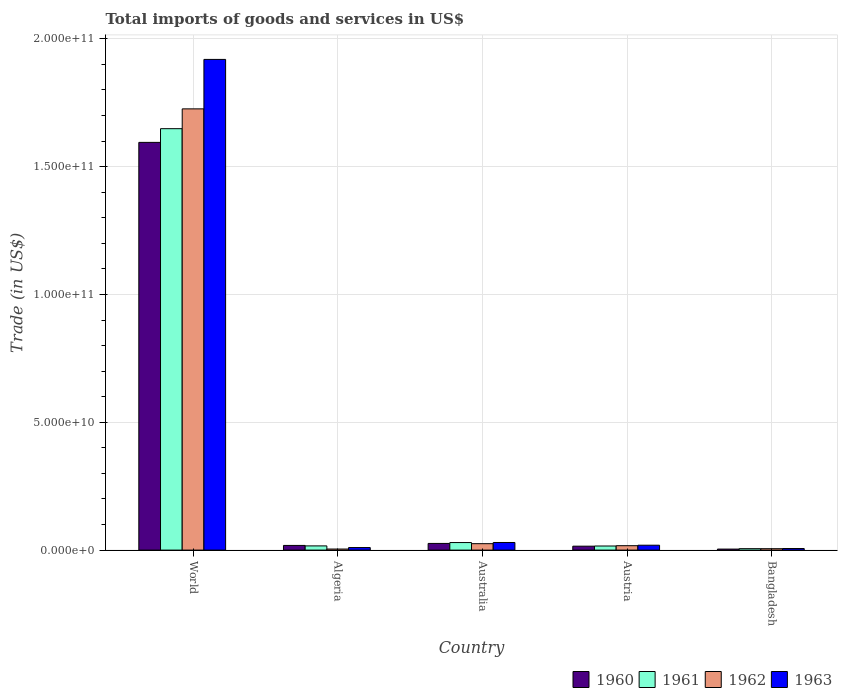How many different coloured bars are there?
Offer a terse response. 4. How many groups of bars are there?
Your answer should be very brief. 5. Are the number of bars per tick equal to the number of legend labels?
Offer a very short reply. Yes. In how many cases, is the number of bars for a given country not equal to the number of legend labels?
Make the answer very short. 0. What is the total imports of goods and services in 1962 in Algeria?
Provide a succinct answer. 4.17e+08. Across all countries, what is the maximum total imports of goods and services in 1962?
Offer a terse response. 1.73e+11. Across all countries, what is the minimum total imports of goods and services in 1962?
Keep it short and to the point. 4.17e+08. In which country was the total imports of goods and services in 1960 maximum?
Your answer should be compact. World. In which country was the total imports of goods and services in 1962 minimum?
Offer a very short reply. Algeria. What is the total total imports of goods and services in 1961 in the graph?
Offer a terse response. 1.72e+11. What is the difference between the total imports of goods and services in 1963 in Australia and that in Austria?
Offer a very short reply. 1.06e+09. What is the difference between the total imports of goods and services in 1961 in World and the total imports of goods and services in 1960 in Austria?
Make the answer very short. 1.63e+11. What is the average total imports of goods and services in 1960 per country?
Your answer should be very brief. 3.32e+1. What is the difference between the total imports of goods and services of/in 1963 and total imports of goods and services of/in 1960 in Bangladesh?
Keep it short and to the point. 2.22e+08. What is the ratio of the total imports of goods and services in 1961 in Algeria to that in World?
Keep it short and to the point. 0.01. Is the difference between the total imports of goods and services in 1963 in Australia and Bangladesh greater than the difference between the total imports of goods and services in 1960 in Australia and Bangladesh?
Your answer should be very brief. Yes. What is the difference between the highest and the second highest total imports of goods and services in 1960?
Keep it short and to the point. -7.83e+08. What is the difference between the highest and the lowest total imports of goods and services in 1961?
Your answer should be compact. 1.64e+11. Is the sum of the total imports of goods and services in 1963 in Austria and Bangladesh greater than the maximum total imports of goods and services in 1961 across all countries?
Offer a very short reply. No. Is it the case that in every country, the sum of the total imports of goods and services in 1962 and total imports of goods and services in 1961 is greater than the sum of total imports of goods and services in 1963 and total imports of goods and services in 1960?
Your answer should be very brief. No. What does the 3rd bar from the left in World represents?
Your answer should be compact. 1962. What does the 3rd bar from the right in Bangladesh represents?
Your response must be concise. 1961. Is it the case that in every country, the sum of the total imports of goods and services in 1961 and total imports of goods and services in 1960 is greater than the total imports of goods and services in 1963?
Provide a short and direct response. Yes. Are the values on the major ticks of Y-axis written in scientific E-notation?
Give a very brief answer. Yes. Does the graph contain grids?
Make the answer very short. Yes. What is the title of the graph?
Your answer should be compact. Total imports of goods and services in US$. Does "2009" appear as one of the legend labels in the graph?
Ensure brevity in your answer.  No. What is the label or title of the Y-axis?
Your answer should be compact. Trade (in US$). What is the Trade (in US$) in 1960 in World?
Provide a succinct answer. 1.59e+11. What is the Trade (in US$) in 1961 in World?
Keep it short and to the point. 1.65e+11. What is the Trade (in US$) of 1962 in World?
Keep it short and to the point. 1.73e+11. What is the Trade (in US$) in 1963 in World?
Offer a terse response. 1.92e+11. What is the Trade (in US$) of 1960 in Algeria?
Your answer should be very brief. 1.83e+09. What is the Trade (in US$) in 1961 in Algeria?
Offer a very short reply. 1.64e+09. What is the Trade (in US$) in 1962 in Algeria?
Make the answer very short. 4.17e+08. What is the Trade (in US$) of 1963 in Algeria?
Your answer should be very brief. 9.95e+08. What is the Trade (in US$) in 1960 in Australia?
Offer a very short reply. 2.61e+09. What is the Trade (in US$) in 1961 in Australia?
Keep it short and to the point. 2.95e+09. What is the Trade (in US$) of 1962 in Australia?
Your answer should be compact. 2.51e+09. What is the Trade (in US$) in 1963 in Australia?
Your answer should be compact. 2.97e+09. What is the Trade (in US$) of 1960 in Austria?
Make the answer very short. 1.53e+09. What is the Trade (in US$) in 1961 in Austria?
Your response must be concise. 1.60e+09. What is the Trade (in US$) of 1962 in Austria?
Offer a terse response. 1.72e+09. What is the Trade (in US$) in 1963 in Austria?
Give a very brief answer. 1.91e+09. What is the Trade (in US$) of 1960 in Bangladesh?
Provide a succinct answer. 3.98e+08. What is the Trade (in US$) of 1961 in Bangladesh?
Provide a succinct answer. 5.64e+08. What is the Trade (in US$) in 1962 in Bangladesh?
Your answer should be compact. 5.49e+08. What is the Trade (in US$) of 1963 in Bangladesh?
Make the answer very short. 6.20e+08. Across all countries, what is the maximum Trade (in US$) of 1960?
Give a very brief answer. 1.59e+11. Across all countries, what is the maximum Trade (in US$) in 1961?
Make the answer very short. 1.65e+11. Across all countries, what is the maximum Trade (in US$) in 1962?
Provide a short and direct response. 1.73e+11. Across all countries, what is the maximum Trade (in US$) in 1963?
Your response must be concise. 1.92e+11. Across all countries, what is the minimum Trade (in US$) of 1960?
Ensure brevity in your answer.  3.98e+08. Across all countries, what is the minimum Trade (in US$) of 1961?
Ensure brevity in your answer.  5.64e+08. Across all countries, what is the minimum Trade (in US$) in 1962?
Provide a succinct answer. 4.17e+08. Across all countries, what is the minimum Trade (in US$) of 1963?
Give a very brief answer. 6.20e+08. What is the total Trade (in US$) in 1960 in the graph?
Offer a very short reply. 1.66e+11. What is the total Trade (in US$) in 1961 in the graph?
Keep it short and to the point. 1.72e+11. What is the total Trade (in US$) of 1962 in the graph?
Your answer should be very brief. 1.78e+11. What is the total Trade (in US$) in 1963 in the graph?
Provide a short and direct response. 1.98e+11. What is the difference between the Trade (in US$) in 1960 in World and that in Algeria?
Offer a terse response. 1.58e+11. What is the difference between the Trade (in US$) in 1961 in World and that in Algeria?
Give a very brief answer. 1.63e+11. What is the difference between the Trade (in US$) of 1962 in World and that in Algeria?
Your answer should be compact. 1.72e+11. What is the difference between the Trade (in US$) of 1963 in World and that in Algeria?
Make the answer very short. 1.91e+11. What is the difference between the Trade (in US$) in 1960 in World and that in Australia?
Give a very brief answer. 1.57e+11. What is the difference between the Trade (in US$) of 1961 in World and that in Australia?
Keep it short and to the point. 1.62e+11. What is the difference between the Trade (in US$) of 1962 in World and that in Australia?
Your answer should be very brief. 1.70e+11. What is the difference between the Trade (in US$) of 1963 in World and that in Australia?
Make the answer very short. 1.89e+11. What is the difference between the Trade (in US$) in 1960 in World and that in Austria?
Ensure brevity in your answer.  1.58e+11. What is the difference between the Trade (in US$) of 1961 in World and that in Austria?
Your answer should be compact. 1.63e+11. What is the difference between the Trade (in US$) of 1962 in World and that in Austria?
Your response must be concise. 1.71e+11. What is the difference between the Trade (in US$) in 1963 in World and that in Austria?
Your answer should be very brief. 1.90e+11. What is the difference between the Trade (in US$) of 1960 in World and that in Bangladesh?
Offer a terse response. 1.59e+11. What is the difference between the Trade (in US$) in 1961 in World and that in Bangladesh?
Your answer should be very brief. 1.64e+11. What is the difference between the Trade (in US$) in 1962 in World and that in Bangladesh?
Your answer should be compact. 1.72e+11. What is the difference between the Trade (in US$) of 1963 in World and that in Bangladesh?
Your answer should be very brief. 1.91e+11. What is the difference between the Trade (in US$) of 1960 in Algeria and that in Australia?
Your response must be concise. -7.83e+08. What is the difference between the Trade (in US$) of 1961 in Algeria and that in Australia?
Offer a terse response. -1.31e+09. What is the difference between the Trade (in US$) of 1962 in Algeria and that in Australia?
Your answer should be very brief. -2.10e+09. What is the difference between the Trade (in US$) in 1963 in Algeria and that in Australia?
Keep it short and to the point. -1.98e+09. What is the difference between the Trade (in US$) of 1960 in Algeria and that in Austria?
Ensure brevity in your answer.  2.95e+08. What is the difference between the Trade (in US$) in 1961 in Algeria and that in Austria?
Your answer should be compact. 4.21e+07. What is the difference between the Trade (in US$) of 1962 in Algeria and that in Austria?
Ensure brevity in your answer.  -1.31e+09. What is the difference between the Trade (in US$) of 1963 in Algeria and that in Austria?
Ensure brevity in your answer.  -9.19e+08. What is the difference between the Trade (in US$) in 1960 in Algeria and that in Bangladesh?
Provide a short and direct response. 1.43e+09. What is the difference between the Trade (in US$) of 1961 in Algeria and that in Bangladesh?
Make the answer very short. 1.08e+09. What is the difference between the Trade (in US$) of 1962 in Algeria and that in Bangladesh?
Provide a succinct answer. -1.33e+08. What is the difference between the Trade (in US$) in 1963 in Algeria and that in Bangladesh?
Provide a succinct answer. 3.75e+08. What is the difference between the Trade (in US$) of 1960 in Australia and that in Austria?
Provide a succinct answer. 1.08e+09. What is the difference between the Trade (in US$) in 1961 in Australia and that in Austria?
Provide a short and direct response. 1.35e+09. What is the difference between the Trade (in US$) of 1962 in Australia and that in Austria?
Your answer should be very brief. 7.90e+08. What is the difference between the Trade (in US$) in 1963 in Australia and that in Austria?
Ensure brevity in your answer.  1.06e+09. What is the difference between the Trade (in US$) of 1960 in Australia and that in Bangladesh?
Provide a succinct answer. 2.21e+09. What is the difference between the Trade (in US$) in 1961 in Australia and that in Bangladesh?
Your response must be concise. 2.39e+09. What is the difference between the Trade (in US$) in 1962 in Australia and that in Bangladesh?
Ensure brevity in your answer.  1.96e+09. What is the difference between the Trade (in US$) in 1963 in Australia and that in Bangladesh?
Provide a succinct answer. 2.35e+09. What is the difference between the Trade (in US$) of 1960 in Austria and that in Bangladesh?
Ensure brevity in your answer.  1.14e+09. What is the difference between the Trade (in US$) in 1961 in Austria and that in Bangladesh?
Provide a short and direct response. 1.04e+09. What is the difference between the Trade (in US$) in 1962 in Austria and that in Bangladesh?
Provide a succinct answer. 1.17e+09. What is the difference between the Trade (in US$) of 1963 in Austria and that in Bangladesh?
Ensure brevity in your answer.  1.29e+09. What is the difference between the Trade (in US$) of 1960 in World and the Trade (in US$) of 1961 in Algeria?
Your answer should be compact. 1.58e+11. What is the difference between the Trade (in US$) of 1960 in World and the Trade (in US$) of 1962 in Algeria?
Keep it short and to the point. 1.59e+11. What is the difference between the Trade (in US$) in 1960 in World and the Trade (in US$) in 1963 in Algeria?
Offer a terse response. 1.58e+11. What is the difference between the Trade (in US$) of 1961 in World and the Trade (in US$) of 1962 in Algeria?
Keep it short and to the point. 1.64e+11. What is the difference between the Trade (in US$) of 1961 in World and the Trade (in US$) of 1963 in Algeria?
Give a very brief answer. 1.64e+11. What is the difference between the Trade (in US$) in 1962 in World and the Trade (in US$) in 1963 in Algeria?
Provide a short and direct response. 1.72e+11. What is the difference between the Trade (in US$) of 1960 in World and the Trade (in US$) of 1961 in Australia?
Keep it short and to the point. 1.57e+11. What is the difference between the Trade (in US$) in 1960 in World and the Trade (in US$) in 1962 in Australia?
Provide a succinct answer. 1.57e+11. What is the difference between the Trade (in US$) in 1960 in World and the Trade (in US$) in 1963 in Australia?
Provide a short and direct response. 1.57e+11. What is the difference between the Trade (in US$) in 1961 in World and the Trade (in US$) in 1962 in Australia?
Your answer should be compact. 1.62e+11. What is the difference between the Trade (in US$) in 1961 in World and the Trade (in US$) in 1963 in Australia?
Keep it short and to the point. 1.62e+11. What is the difference between the Trade (in US$) in 1962 in World and the Trade (in US$) in 1963 in Australia?
Make the answer very short. 1.70e+11. What is the difference between the Trade (in US$) of 1960 in World and the Trade (in US$) of 1961 in Austria?
Provide a short and direct response. 1.58e+11. What is the difference between the Trade (in US$) of 1960 in World and the Trade (in US$) of 1962 in Austria?
Offer a terse response. 1.58e+11. What is the difference between the Trade (in US$) in 1960 in World and the Trade (in US$) in 1963 in Austria?
Your answer should be compact. 1.58e+11. What is the difference between the Trade (in US$) in 1961 in World and the Trade (in US$) in 1962 in Austria?
Your response must be concise. 1.63e+11. What is the difference between the Trade (in US$) of 1961 in World and the Trade (in US$) of 1963 in Austria?
Your answer should be very brief. 1.63e+11. What is the difference between the Trade (in US$) in 1962 in World and the Trade (in US$) in 1963 in Austria?
Your answer should be very brief. 1.71e+11. What is the difference between the Trade (in US$) in 1960 in World and the Trade (in US$) in 1961 in Bangladesh?
Ensure brevity in your answer.  1.59e+11. What is the difference between the Trade (in US$) in 1960 in World and the Trade (in US$) in 1962 in Bangladesh?
Offer a very short reply. 1.59e+11. What is the difference between the Trade (in US$) of 1960 in World and the Trade (in US$) of 1963 in Bangladesh?
Offer a terse response. 1.59e+11. What is the difference between the Trade (in US$) in 1961 in World and the Trade (in US$) in 1962 in Bangladesh?
Your answer should be compact. 1.64e+11. What is the difference between the Trade (in US$) in 1961 in World and the Trade (in US$) in 1963 in Bangladesh?
Your answer should be compact. 1.64e+11. What is the difference between the Trade (in US$) in 1962 in World and the Trade (in US$) in 1963 in Bangladesh?
Your response must be concise. 1.72e+11. What is the difference between the Trade (in US$) in 1960 in Algeria and the Trade (in US$) in 1961 in Australia?
Make the answer very short. -1.12e+09. What is the difference between the Trade (in US$) of 1960 in Algeria and the Trade (in US$) of 1962 in Australia?
Ensure brevity in your answer.  -6.83e+08. What is the difference between the Trade (in US$) of 1960 in Algeria and the Trade (in US$) of 1963 in Australia?
Make the answer very short. -1.15e+09. What is the difference between the Trade (in US$) in 1961 in Algeria and the Trade (in US$) in 1962 in Australia?
Ensure brevity in your answer.  -8.68e+08. What is the difference between the Trade (in US$) of 1961 in Algeria and the Trade (in US$) of 1963 in Australia?
Provide a succinct answer. -1.33e+09. What is the difference between the Trade (in US$) in 1962 in Algeria and the Trade (in US$) in 1963 in Australia?
Your response must be concise. -2.56e+09. What is the difference between the Trade (in US$) of 1960 in Algeria and the Trade (in US$) of 1961 in Austria?
Offer a terse response. 2.27e+08. What is the difference between the Trade (in US$) in 1960 in Algeria and the Trade (in US$) in 1962 in Austria?
Make the answer very short. 1.07e+08. What is the difference between the Trade (in US$) in 1960 in Algeria and the Trade (in US$) in 1963 in Austria?
Your response must be concise. -8.54e+07. What is the difference between the Trade (in US$) in 1961 in Algeria and the Trade (in US$) in 1962 in Austria?
Keep it short and to the point. -7.84e+07. What is the difference between the Trade (in US$) in 1961 in Algeria and the Trade (in US$) in 1963 in Austria?
Your answer should be compact. -2.71e+08. What is the difference between the Trade (in US$) in 1962 in Algeria and the Trade (in US$) in 1963 in Austria?
Provide a short and direct response. -1.50e+09. What is the difference between the Trade (in US$) in 1960 in Algeria and the Trade (in US$) in 1961 in Bangladesh?
Offer a terse response. 1.27e+09. What is the difference between the Trade (in US$) in 1960 in Algeria and the Trade (in US$) in 1962 in Bangladesh?
Provide a succinct answer. 1.28e+09. What is the difference between the Trade (in US$) of 1960 in Algeria and the Trade (in US$) of 1963 in Bangladesh?
Give a very brief answer. 1.21e+09. What is the difference between the Trade (in US$) of 1961 in Algeria and the Trade (in US$) of 1962 in Bangladesh?
Make the answer very short. 1.09e+09. What is the difference between the Trade (in US$) of 1961 in Algeria and the Trade (in US$) of 1963 in Bangladesh?
Ensure brevity in your answer.  1.02e+09. What is the difference between the Trade (in US$) of 1962 in Algeria and the Trade (in US$) of 1963 in Bangladesh?
Ensure brevity in your answer.  -2.03e+08. What is the difference between the Trade (in US$) in 1960 in Australia and the Trade (in US$) in 1961 in Austria?
Your response must be concise. 1.01e+09. What is the difference between the Trade (in US$) of 1960 in Australia and the Trade (in US$) of 1962 in Austria?
Offer a terse response. 8.90e+08. What is the difference between the Trade (in US$) of 1960 in Australia and the Trade (in US$) of 1963 in Austria?
Provide a short and direct response. 6.98e+08. What is the difference between the Trade (in US$) of 1961 in Australia and the Trade (in US$) of 1962 in Austria?
Your response must be concise. 1.23e+09. What is the difference between the Trade (in US$) in 1961 in Australia and the Trade (in US$) in 1963 in Austria?
Provide a succinct answer. 1.04e+09. What is the difference between the Trade (in US$) in 1962 in Australia and the Trade (in US$) in 1963 in Austria?
Provide a succinct answer. 5.98e+08. What is the difference between the Trade (in US$) of 1960 in Australia and the Trade (in US$) of 1961 in Bangladesh?
Make the answer very short. 2.05e+09. What is the difference between the Trade (in US$) in 1960 in Australia and the Trade (in US$) in 1962 in Bangladesh?
Keep it short and to the point. 2.06e+09. What is the difference between the Trade (in US$) of 1960 in Australia and the Trade (in US$) of 1963 in Bangladesh?
Ensure brevity in your answer.  1.99e+09. What is the difference between the Trade (in US$) of 1961 in Australia and the Trade (in US$) of 1962 in Bangladesh?
Give a very brief answer. 2.40e+09. What is the difference between the Trade (in US$) in 1961 in Australia and the Trade (in US$) in 1963 in Bangladesh?
Give a very brief answer. 2.33e+09. What is the difference between the Trade (in US$) in 1962 in Australia and the Trade (in US$) in 1963 in Bangladesh?
Offer a very short reply. 1.89e+09. What is the difference between the Trade (in US$) in 1960 in Austria and the Trade (in US$) in 1961 in Bangladesh?
Your response must be concise. 9.70e+08. What is the difference between the Trade (in US$) in 1960 in Austria and the Trade (in US$) in 1962 in Bangladesh?
Your response must be concise. 9.84e+08. What is the difference between the Trade (in US$) in 1960 in Austria and the Trade (in US$) in 1963 in Bangladesh?
Provide a succinct answer. 9.14e+08. What is the difference between the Trade (in US$) in 1961 in Austria and the Trade (in US$) in 1962 in Bangladesh?
Provide a short and direct response. 1.05e+09. What is the difference between the Trade (in US$) of 1961 in Austria and the Trade (in US$) of 1963 in Bangladesh?
Provide a short and direct response. 9.81e+08. What is the difference between the Trade (in US$) in 1962 in Austria and the Trade (in US$) in 1963 in Bangladesh?
Your answer should be compact. 1.10e+09. What is the average Trade (in US$) of 1960 per country?
Make the answer very short. 3.32e+1. What is the average Trade (in US$) in 1961 per country?
Provide a short and direct response. 3.43e+1. What is the average Trade (in US$) in 1962 per country?
Keep it short and to the point. 3.56e+1. What is the average Trade (in US$) in 1963 per country?
Ensure brevity in your answer.  3.97e+1. What is the difference between the Trade (in US$) in 1960 and Trade (in US$) in 1961 in World?
Keep it short and to the point. -5.36e+09. What is the difference between the Trade (in US$) of 1960 and Trade (in US$) of 1962 in World?
Provide a succinct answer. -1.31e+1. What is the difference between the Trade (in US$) in 1960 and Trade (in US$) in 1963 in World?
Your response must be concise. -3.25e+1. What is the difference between the Trade (in US$) of 1961 and Trade (in US$) of 1962 in World?
Your response must be concise. -7.75e+09. What is the difference between the Trade (in US$) of 1961 and Trade (in US$) of 1963 in World?
Make the answer very short. -2.71e+1. What is the difference between the Trade (in US$) in 1962 and Trade (in US$) in 1963 in World?
Ensure brevity in your answer.  -1.93e+1. What is the difference between the Trade (in US$) in 1960 and Trade (in US$) in 1961 in Algeria?
Offer a terse response. 1.85e+08. What is the difference between the Trade (in US$) of 1960 and Trade (in US$) of 1962 in Algeria?
Make the answer very short. 1.41e+09. What is the difference between the Trade (in US$) in 1960 and Trade (in US$) in 1963 in Algeria?
Your answer should be compact. 8.33e+08. What is the difference between the Trade (in US$) in 1961 and Trade (in US$) in 1962 in Algeria?
Make the answer very short. 1.23e+09. What is the difference between the Trade (in US$) in 1961 and Trade (in US$) in 1963 in Algeria?
Your answer should be very brief. 6.48e+08. What is the difference between the Trade (in US$) of 1962 and Trade (in US$) of 1963 in Algeria?
Your answer should be very brief. -5.79e+08. What is the difference between the Trade (in US$) of 1960 and Trade (in US$) of 1961 in Australia?
Offer a terse response. -3.40e+08. What is the difference between the Trade (in US$) of 1960 and Trade (in US$) of 1962 in Australia?
Your answer should be compact. 9.97e+07. What is the difference between the Trade (in US$) in 1960 and Trade (in US$) in 1963 in Australia?
Your response must be concise. -3.63e+08. What is the difference between the Trade (in US$) of 1961 and Trade (in US$) of 1962 in Australia?
Offer a very short reply. 4.40e+08. What is the difference between the Trade (in US$) in 1961 and Trade (in US$) in 1963 in Australia?
Offer a very short reply. -2.24e+07. What is the difference between the Trade (in US$) of 1962 and Trade (in US$) of 1963 in Australia?
Ensure brevity in your answer.  -4.63e+08. What is the difference between the Trade (in US$) of 1960 and Trade (in US$) of 1961 in Austria?
Offer a terse response. -6.78e+07. What is the difference between the Trade (in US$) of 1960 and Trade (in US$) of 1962 in Austria?
Your response must be concise. -1.88e+08. What is the difference between the Trade (in US$) of 1960 and Trade (in US$) of 1963 in Austria?
Keep it short and to the point. -3.81e+08. What is the difference between the Trade (in US$) in 1961 and Trade (in US$) in 1962 in Austria?
Give a very brief answer. -1.21e+08. What is the difference between the Trade (in US$) of 1961 and Trade (in US$) of 1963 in Austria?
Your answer should be very brief. -3.13e+08. What is the difference between the Trade (in US$) of 1962 and Trade (in US$) of 1963 in Austria?
Give a very brief answer. -1.92e+08. What is the difference between the Trade (in US$) of 1960 and Trade (in US$) of 1961 in Bangladesh?
Offer a very short reply. -1.66e+08. What is the difference between the Trade (in US$) of 1960 and Trade (in US$) of 1962 in Bangladesh?
Offer a very short reply. -1.51e+08. What is the difference between the Trade (in US$) in 1960 and Trade (in US$) in 1963 in Bangladesh?
Offer a terse response. -2.22e+08. What is the difference between the Trade (in US$) in 1961 and Trade (in US$) in 1962 in Bangladesh?
Provide a succinct answer. 1.45e+07. What is the difference between the Trade (in US$) in 1961 and Trade (in US$) in 1963 in Bangladesh?
Your response must be concise. -5.64e+07. What is the difference between the Trade (in US$) in 1962 and Trade (in US$) in 1963 in Bangladesh?
Ensure brevity in your answer.  -7.08e+07. What is the ratio of the Trade (in US$) of 1960 in World to that in Algeria?
Your response must be concise. 87.21. What is the ratio of the Trade (in US$) in 1961 in World to that in Algeria?
Provide a succinct answer. 100.3. What is the ratio of the Trade (in US$) of 1962 in World to that in Algeria?
Offer a very short reply. 414.23. What is the ratio of the Trade (in US$) of 1963 in World to that in Algeria?
Keep it short and to the point. 192.84. What is the ratio of the Trade (in US$) in 1960 in World to that in Australia?
Your answer should be very brief. 61.07. What is the ratio of the Trade (in US$) in 1961 in World to that in Australia?
Your answer should be very brief. 55.84. What is the ratio of the Trade (in US$) of 1962 in World to that in Australia?
Make the answer very short. 68.71. What is the ratio of the Trade (in US$) in 1963 in World to that in Australia?
Ensure brevity in your answer.  64.53. What is the ratio of the Trade (in US$) of 1960 in World to that in Austria?
Offer a terse response. 104. What is the ratio of the Trade (in US$) in 1961 in World to that in Austria?
Keep it short and to the point. 102.94. What is the ratio of the Trade (in US$) in 1962 in World to that in Austria?
Make the answer very short. 100.23. What is the ratio of the Trade (in US$) in 1963 in World to that in Austria?
Give a very brief answer. 100.28. What is the ratio of the Trade (in US$) of 1960 in World to that in Bangladesh?
Provide a short and direct response. 400.86. What is the ratio of the Trade (in US$) in 1961 in World to that in Bangladesh?
Offer a terse response. 292.47. What is the ratio of the Trade (in US$) of 1962 in World to that in Bangladesh?
Ensure brevity in your answer.  314.28. What is the ratio of the Trade (in US$) in 1963 in World to that in Bangladesh?
Your response must be concise. 309.57. What is the ratio of the Trade (in US$) in 1960 in Algeria to that in Australia?
Make the answer very short. 0.7. What is the ratio of the Trade (in US$) of 1961 in Algeria to that in Australia?
Make the answer very short. 0.56. What is the ratio of the Trade (in US$) of 1962 in Algeria to that in Australia?
Offer a very short reply. 0.17. What is the ratio of the Trade (in US$) in 1963 in Algeria to that in Australia?
Your answer should be compact. 0.33. What is the ratio of the Trade (in US$) of 1960 in Algeria to that in Austria?
Ensure brevity in your answer.  1.19. What is the ratio of the Trade (in US$) of 1961 in Algeria to that in Austria?
Offer a terse response. 1.03. What is the ratio of the Trade (in US$) in 1962 in Algeria to that in Austria?
Ensure brevity in your answer.  0.24. What is the ratio of the Trade (in US$) in 1963 in Algeria to that in Austria?
Ensure brevity in your answer.  0.52. What is the ratio of the Trade (in US$) in 1960 in Algeria to that in Bangladesh?
Ensure brevity in your answer.  4.6. What is the ratio of the Trade (in US$) in 1961 in Algeria to that in Bangladesh?
Keep it short and to the point. 2.92. What is the ratio of the Trade (in US$) of 1962 in Algeria to that in Bangladesh?
Make the answer very short. 0.76. What is the ratio of the Trade (in US$) in 1963 in Algeria to that in Bangladesh?
Keep it short and to the point. 1.61. What is the ratio of the Trade (in US$) in 1960 in Australia to that in Austria?
Give a very brief answer. 1.7. What is the ratio of the Trade (in US$) of 1961 in Australia to that in Austria?
Your response must be concise. 1.84. What is the ratio of the Trade (in US$) of 1962 in Australia to that in Austria?
Your response must be concise. 1.46. What is the ratio of the Trade (in US$) in 1963 in Australia to that in Austria?
Your answer should be very brief. 1.55. What is the ratio of the Trade (in US$) of 1960 in Australia to that in Bangladesh?
Your answer should be very brief. 6.56. What is the ratio of the Trade (in US$) of 1961 in Australia to that in Bangladesh?
Your answer should be compact. 5.24. What is the ratio of the Trade (in US$) of 1962 in Australia to that in Bangladesh?
Give a very brief answer. 4.57. What is the ratio of the Trade (in US$) of 1963 in Australia to that in Bangladesh?
Ensure brevity in your answer.  4.8. What is the ratio of the Trade (in US$) of 1960 in Austria to that in Bangladesh?
Your response must be concise. 3.85. What is the ratio of the Trade (in US$) of 1961 in Austria to that in Bangladesh?
Provide a short and direct response. 2.84. What is the ratio of the Trade (in US$) in 1962 in Austria to that in Bangladesh?
Provide a succinct answer. 3.14. What is the ratio of the Trade (in US$) in 1963 in Austria to that in Bangladesh?
Your answer should be compact. 3.09. What is the difference between the highest and the second highest Trade (in US$) in 1960?
Your answer should be very brief. 1.57e+11. What is the difference between the highest and the second highest Trade (in US$) of 1961?
Give a very brief answer. 1.62e+11. What is the difference between the highest and the second highest Trade (in US$) of 1962?
Provide a succinct answer. 1.70e+11. What is the difference between the highest and the second highest Trade (in US$) in 1963?
Provide a succinct answer. 1.89e+11. What is the difference between the highest and the lowest Trade (in US$) of 1960?
Offer a terse response. 1.59e+11. What is the difference between the highest and the lowest Trade (in US$) of 1961?
Your response must be concise. 1.64e+11. What is the difference between the highest and the lowest Trade (in US$) of 1962?
Your answer should be very brief. 1.72e+11. What is the difference between the highest and the lowest Trade (in US$) of 1963?
Offer a very short reply. 1.91e+11. 